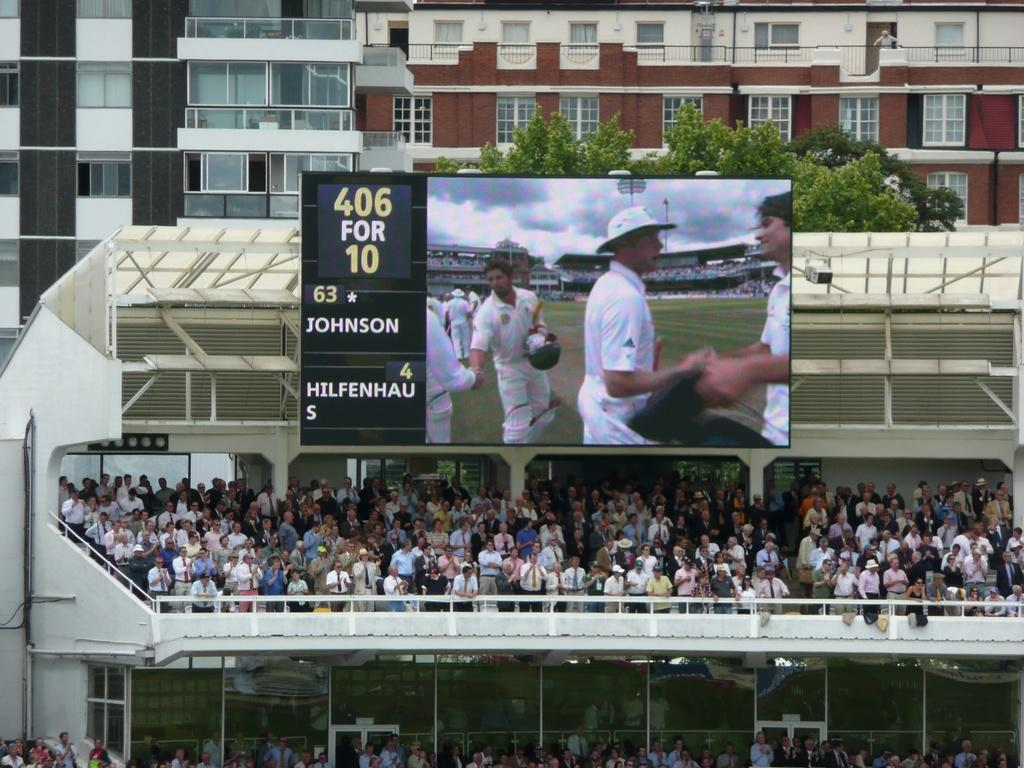<image>
Share a concise interpretation of the image provided. Scoreboard showing people shaking hands and the name JOHNSON on it. 